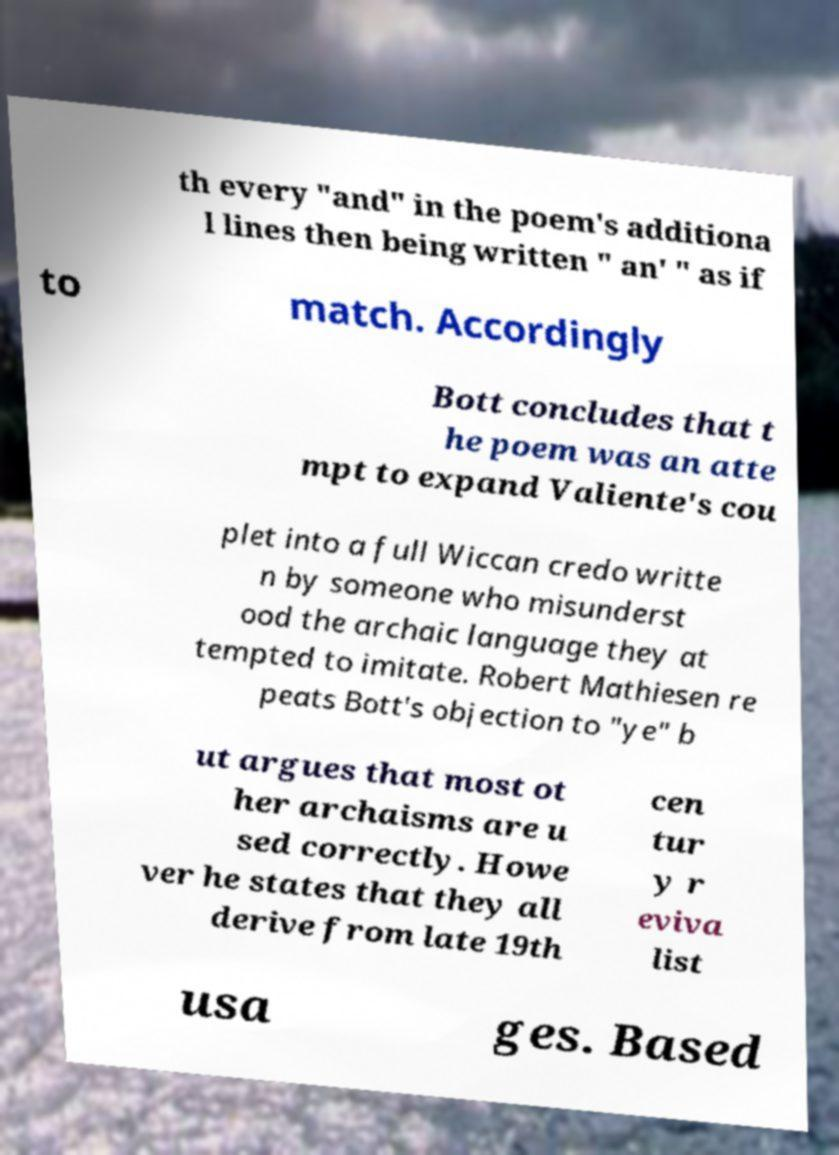Please identify and transcribe the text found in this image. th every "and" in the poem's additiona l lines then being written " an' " as if to match. Accordingly Bott concludes that t he poem was an atte mpt to expand Valiente's cou plet into a full Wiccan credo writte n by someone who misunderst ood the archaic language they at tempted to imitate. Robert Mathiesen re peats Bott's objection to "ye" b ut argues that most ot her archaisms are u sed correctly. Howe ver he states that they all derive from late 19th cen tur y r eviva list usa ges. Based 